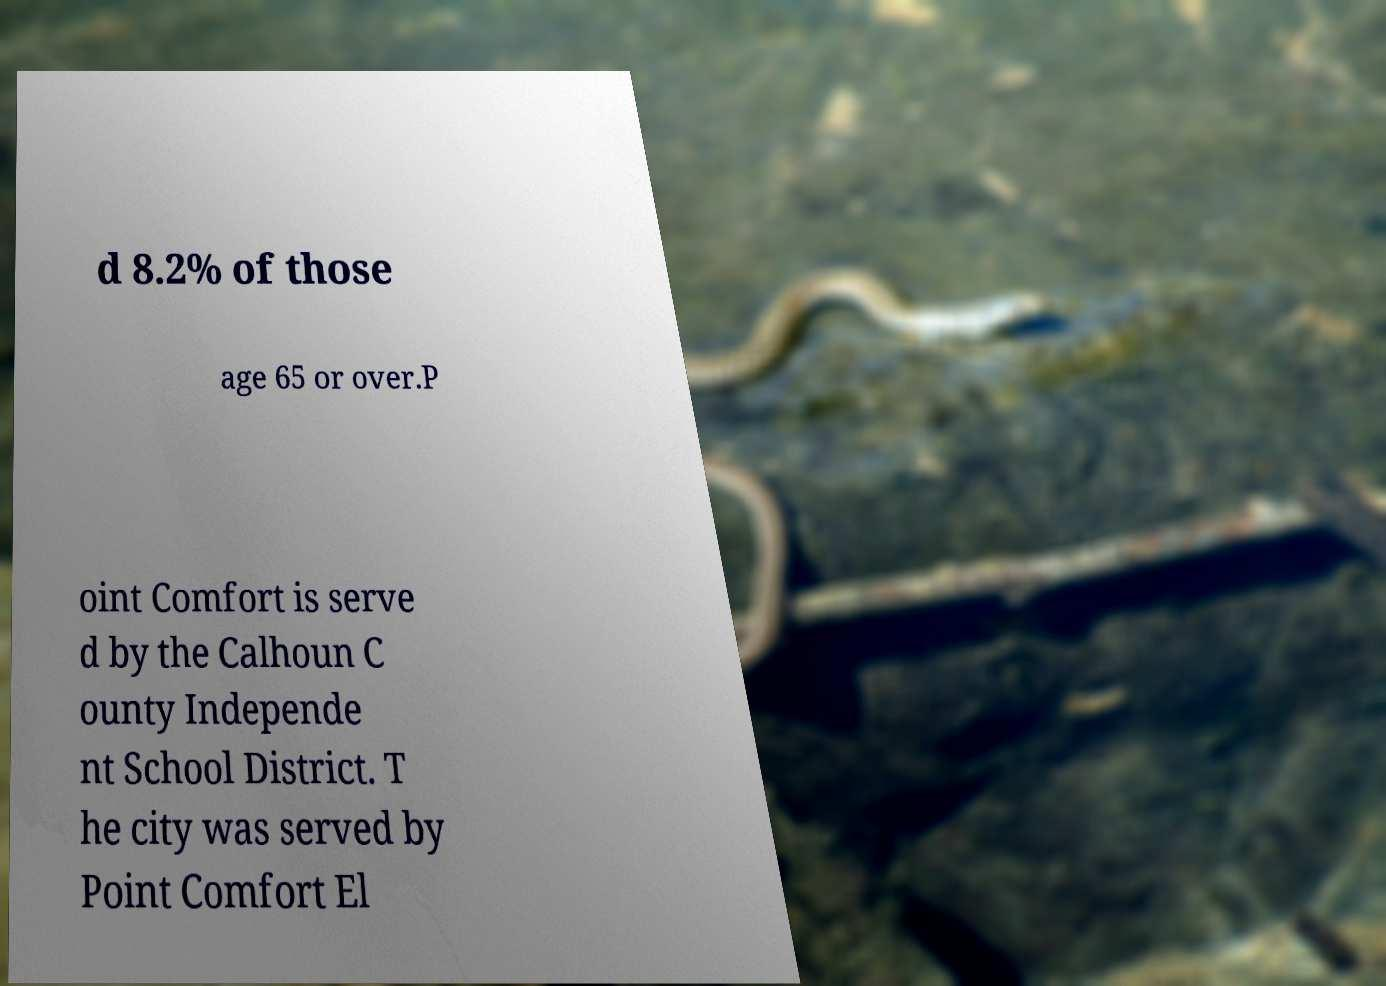What messages or text are displayed in this image? I need them in a readable, typed format. d 8.2% of those age 65 or over.P oint Comfort is serve d by the Calhoun C ounty Independe nt School District. T he city was served by Point Comfort El 